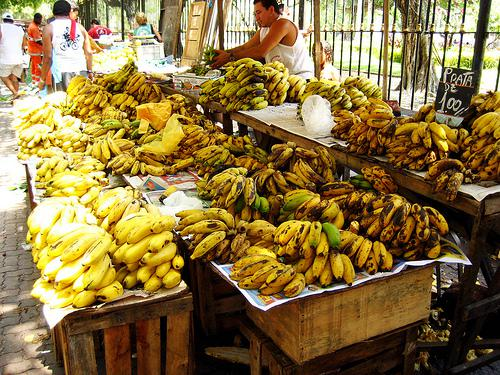Question: where was the photo taken?
Choices:
A. At a roadside market.
B. Outside.
C. In the city.
D. Side of the highway.
Answer with the letter. Answer: A Question: who is holding bananas?
Choices:
A. Woman with a dog.
B. Twin girls.
C. Teenage boy.
D. Man in white.
Answer with the letter. Answer: D Question: how many people are wearing white tank tops?
Choices:
A. Four.
B. Three.
C. Five.
D. Two.
Answer with the letter. Answer: D Question: where are shadows?
Choices:
A. On the table.
B. On the wall.
C. In the grass.
D. On the ground.
Answer with the letter. Answer: D Question: what is being displayed?
Choices:
A. Many bananas.
B. Apples.
C. Ceramic Dolls.
D. Dog toys.
Answer with the letter. Answer: A Question: why are bananas being displayed?
Choices:
A. To be sold.
B. For a picture.
C. To be donated to homeless people.
D. To be fed to the monkeys.
Answer with the letter. Answer: A 